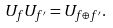<formula> <loc_0><loc_0><loc_500><loc_500>U _ { f } U _ { f ^ { \prime } } = U _ { f { \oplus } f ^ { \prime } } .</formula> 